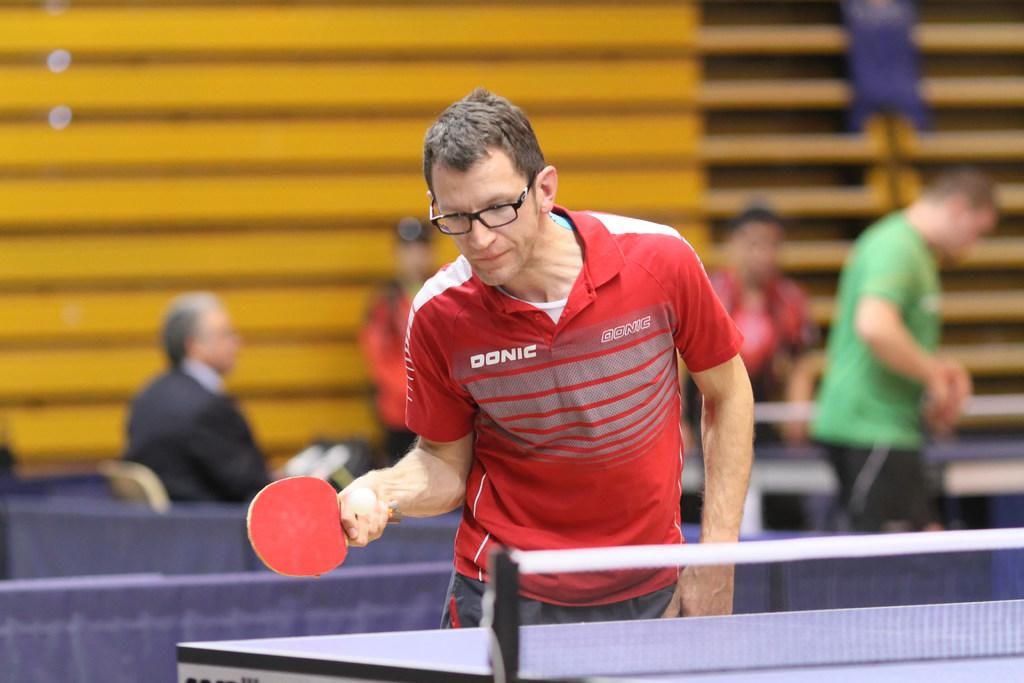Who is the main subject in the image? There is a man in the image. What is the man wearing on his face? The man is wearing spectacles. What color is the t-shirt the man is wearing? The man is wearing a red t-shirt. What activity is the man engaged in? The man is playing table tennis. What separates the two sides of the table tennis game? There is a net in the image. How would you describe the background of the image? The background of the image is blurry. What are the other people in the image doing? There are persons sitting and standing in the background. What type of shoe is the woman wearing in the image? There is no woman present in the image, so it is not possible to determine what type of shoe she might be wearing. 